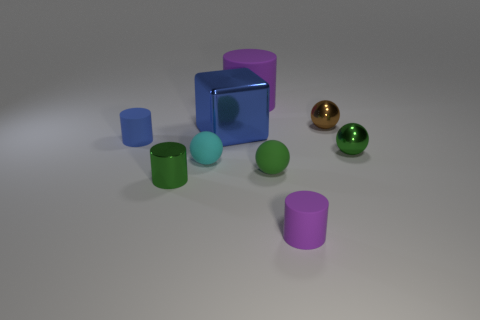What is the overall color scheme of the objects in the image? The image features objects with a variety of colors, including cyan, magenta, green, and gold. These colors give a vibrant contrast against the neutral background. 